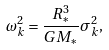<formula> <loc_0><loc_0><loc_500><loc_500>\omega _ { k } ^ { 2 } = \frac { R _ { * } ^ { 3 } } { G M _ { * } } \sigma _ { k } ^ { 2 } ,</formula> 